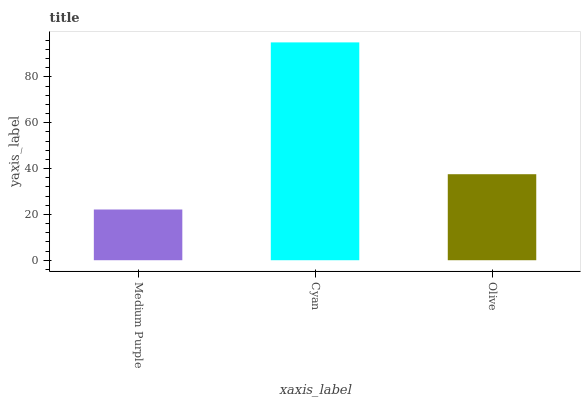Is Medium Purple the minimum?
Answer yes or no. Yes. Is Cyan the maximum?
Answer yes or no. Yes. Is Olive the minimum?
Answer yes or no. No. Is Olive the maximum?
Answer yes or no. No. Is Cyan greater than Olive?
Answer yes or no. Yes. Is Olive less than Cyan?
Answer yes or no. Yes. Is Olive greater than Cyan?
Answer yes or no. No. Is Cyan less than Olive?
Answer yes or no. No. Is Olive the high median?
Answer yes or no. Yes. Is Olive the low median?
Answer yes or no. Yes. Is Cyan the high median?
Answer yes or no. No. Is Cyan the low median?
Answer yes or no. No. 